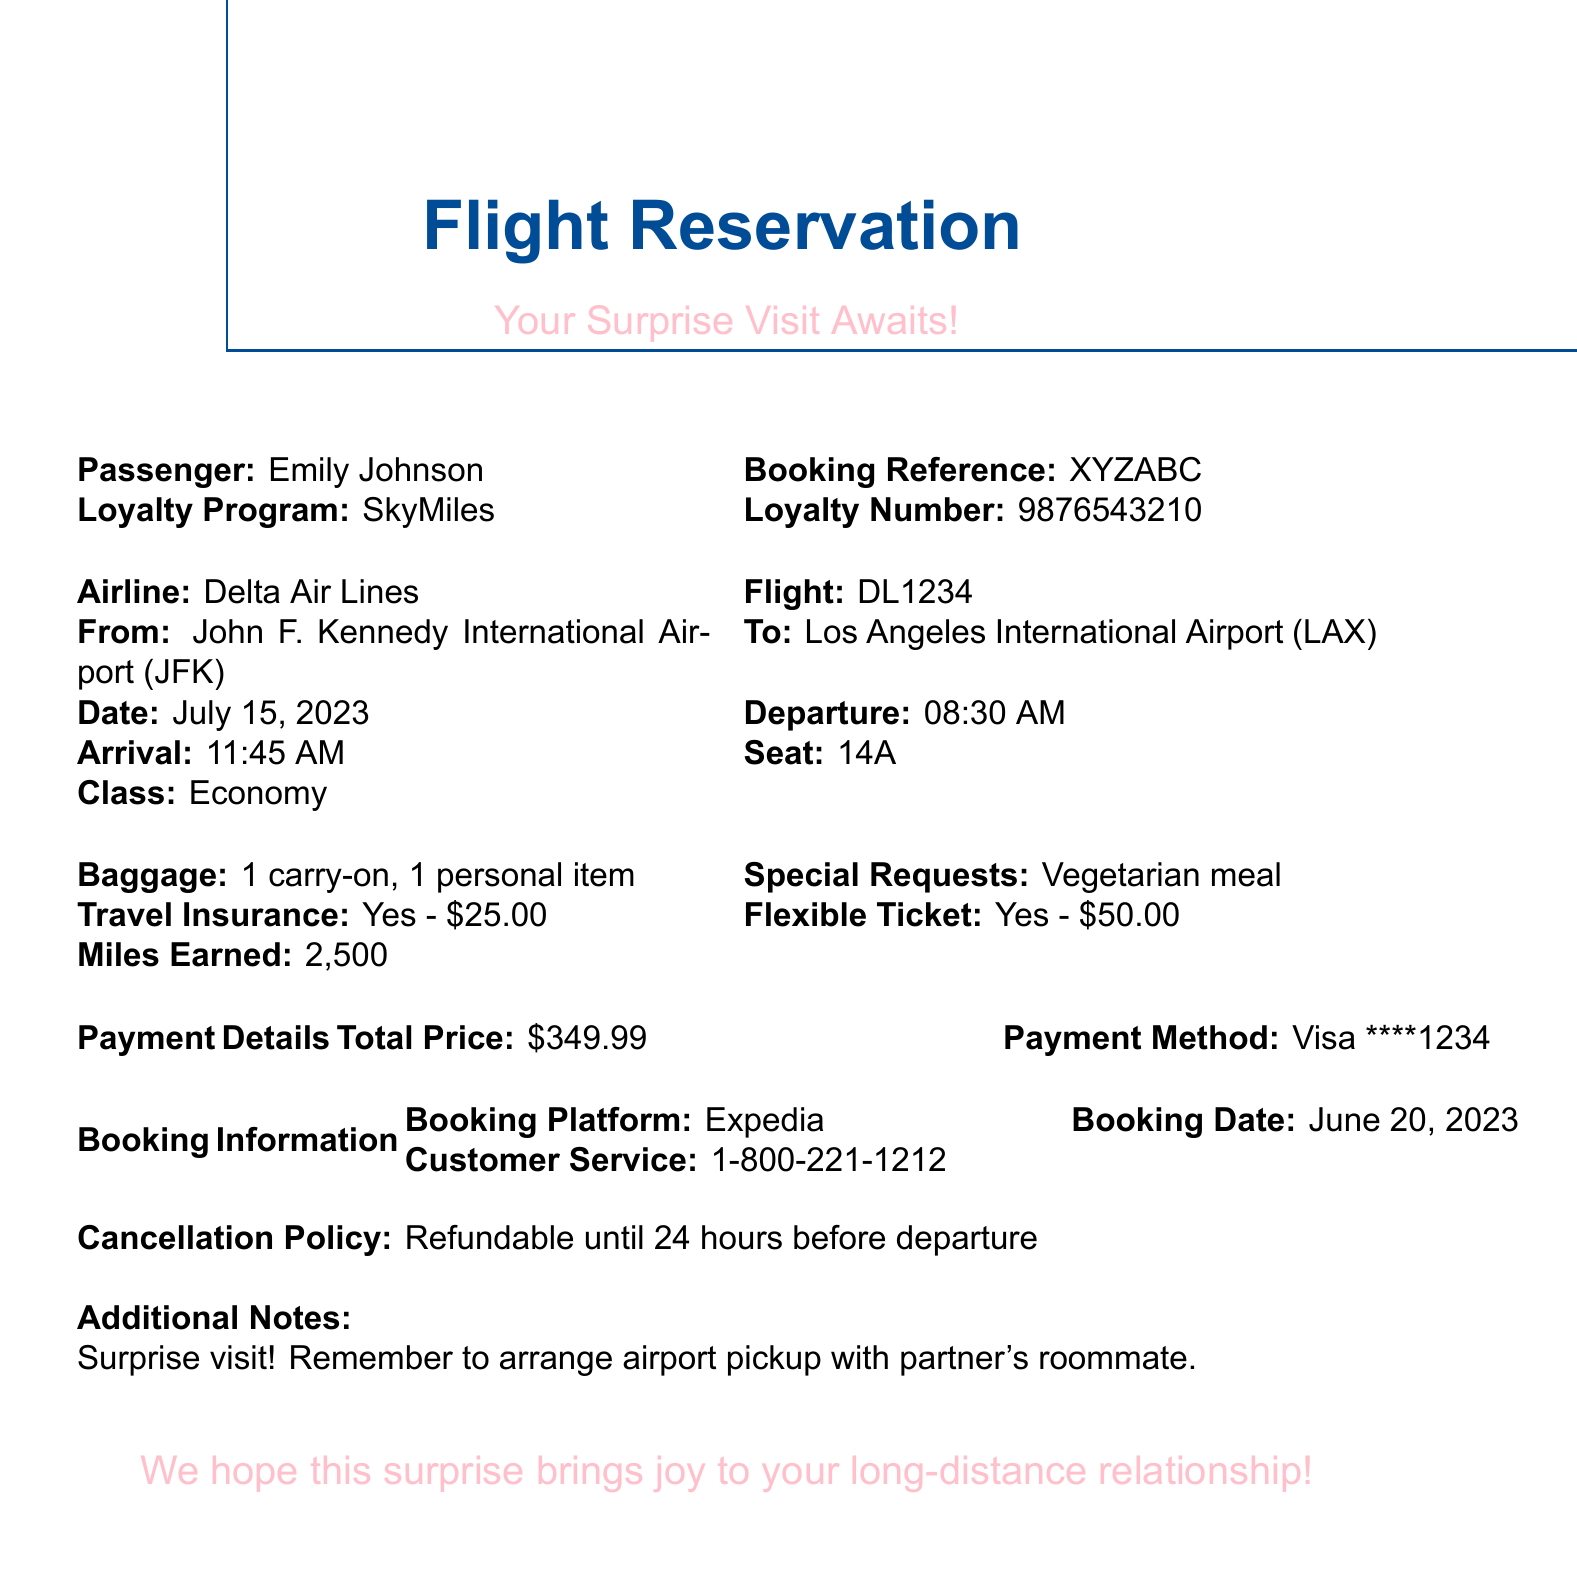What is the airline? The airline is mentioned clearly in the document as one of the main details included in the reservation.
Answer: Delta Air Lines What is the flight number? The flight number is specified in the document, indicating the unique code for the trip booked.
Answer: DL1234 When is the departure date? The departure date is explicitly listed in the reservation details, indicating when the flight will take off.
Answer: July 15, 2023 What is the total price of the ticket? The total price is stated in the 'Payment Details' section, providing the overall cost for the flight.
Answer: $349.99 Is the travel insurance included? The document mentions whether travel insurance is part of the booking, providing clarity on this aspect.
Answer: Yes How many miles will be earned? The mileage earned from this booking is specified in the document, indicating benefits from the loyalty program.
Answer: 2,500 What special request was made? The special request section of the document details any accommodations made for the passenger's needs.
Answer: Vegetarian meal What is the cancellation policy? The cancellation policy is presented in the document, informing how the booking can be modified.
Answer: Refundable until 24 hours before departure Was the ticket flexible? The document mentions the flexibility of the ticket, indicating if date changes are possible without penalty.
Answer: Yes - $50.00 (allows one free date change) Who should be contacted for customer service? The customer service information is provided to assist with any inquiries related to the booking.
Answer: 1-800-221-1212 